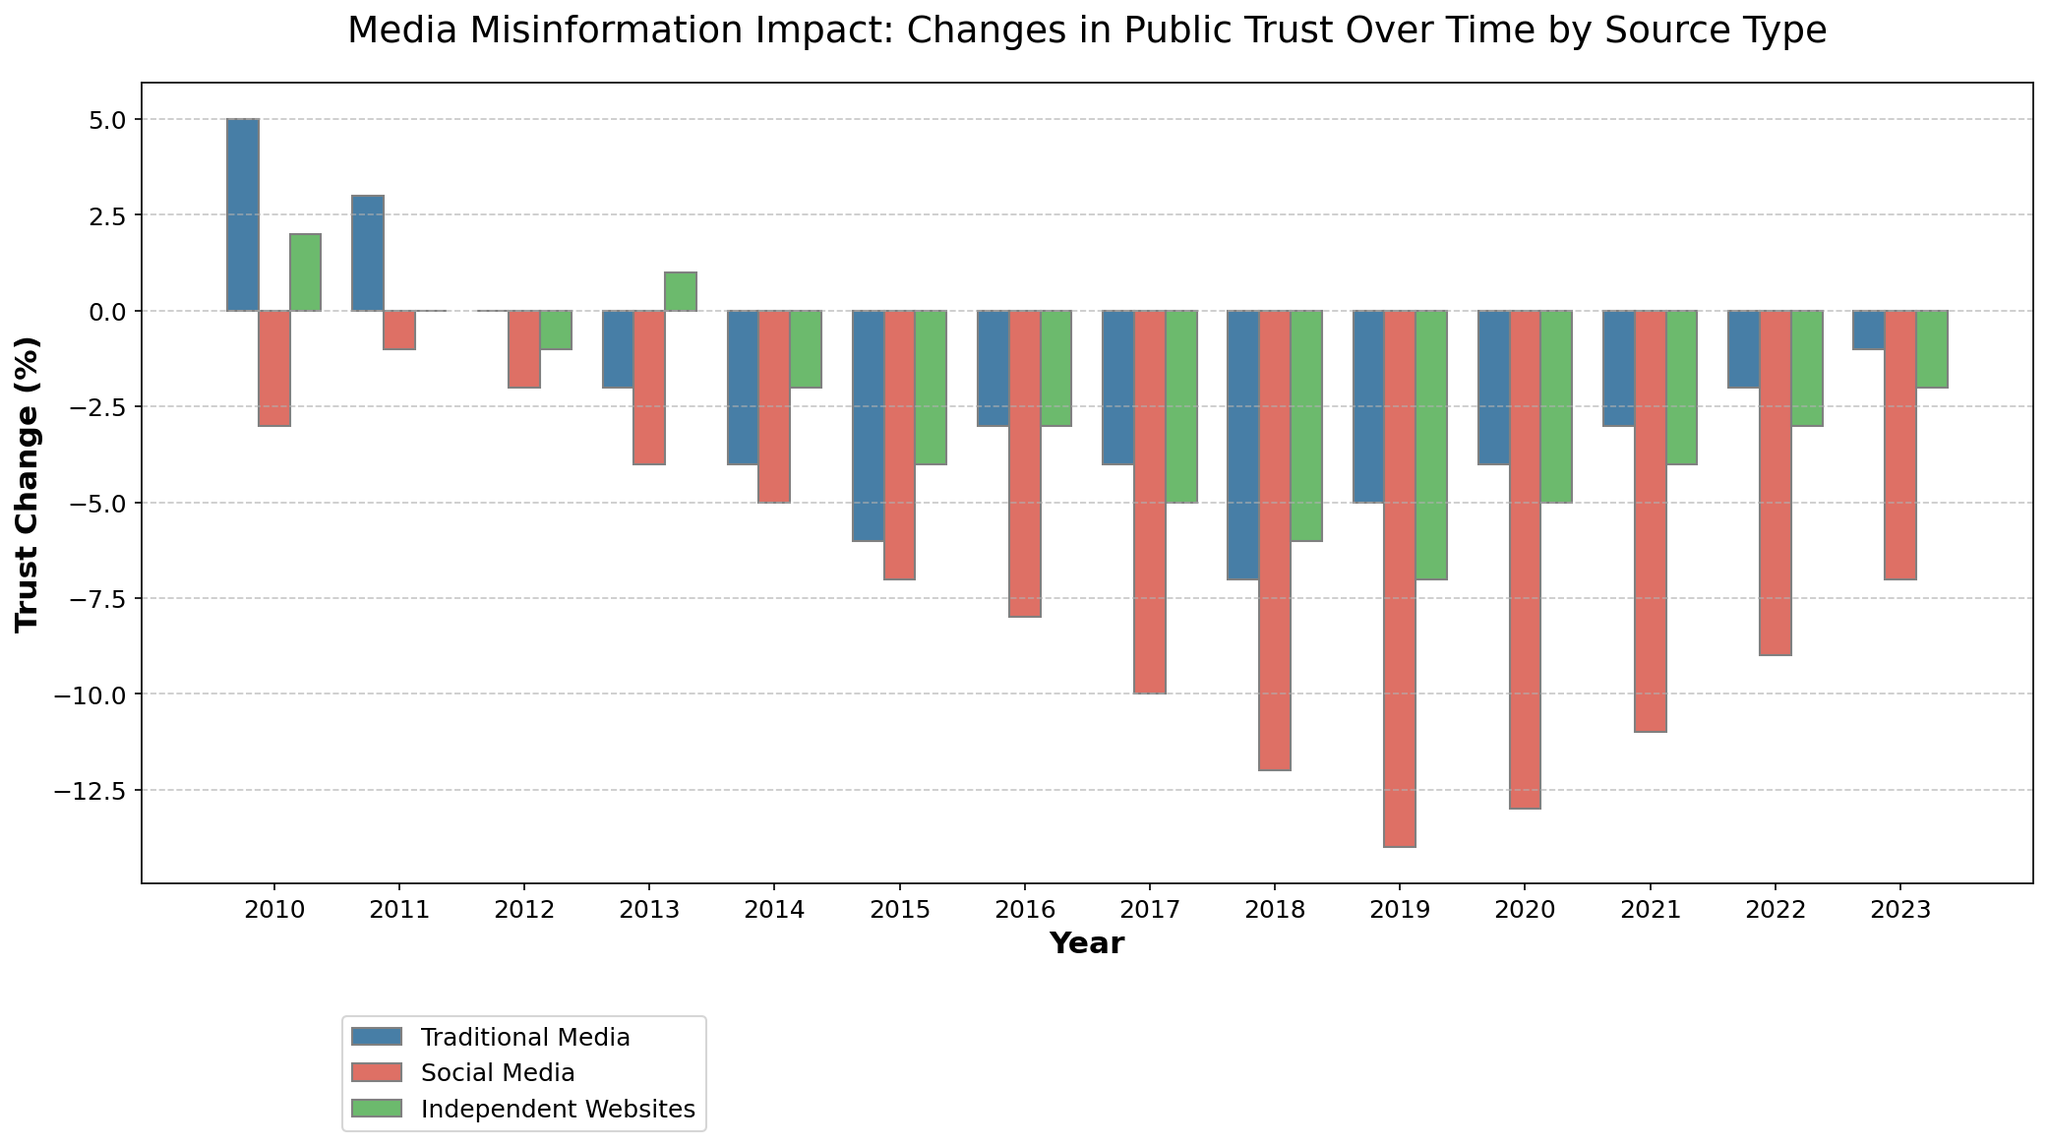Which source type had the largest negative change in public trust in 2019? To find this, look at the height of the bars representing different source types for the year 2019. The tallest bar below zero indicates the largest negative change.
Answer: Social Media How did the change in public trust for Independent Websites behave from 2016 to 2020? Examine the bars for Independent Websites from 2016 to 2020. Identify the trend by comparing the height of the bars year by year.
Answer: It decreased from -3 to -5 and then improved to -4 Comparing 2010 and 2018, how did the change in public trust for Traditional Media differ? Look at the height of the bars for Traditional Media in 2010 and 2018. Subtract the trust change in 2010 from the trust change in 2018 to get the difference.
Answer: -12 Which year did Social Media see the worst change in public trust? Identify the year where the Social Media bar is the tallest below zero, indicating the worst change in public trust.
Answer: 2019 What is the average trust change for Traditional Media from 2010 to 2023? Calculate the sum of trust changes for Traditional Media from 2010 to 2023, then divide by the total number of years (14). Sum: 5 + 3 + 0 - 2 - 4 - 6 - 3 - 4 - 7 - 5 - 4 - 3 - 2 - 1 = -34. Average = -34/14.
Answer: -2.43 In which year did all source types see a negative change in public trust? Look for the year where all bars (for Traditional Media, Social Media, and Independent Websites) are below zero.
Answer: 2014 Which source showed a steady improvement or least variation in public trust change from 2010 to 2023? Examine the bars over the years for each source type. Identify the source type where changes are consistently close to zero.
Answer: Independent Websites What is the difference between the best and worst year of trust change for Social Media? Identify the year with the highest trust change and the year with the lowest trust change for Social Media. Subtract these values. Best: -1 (2011), Worst: -14 (2019). Difference: -1 - (-14) = 13.
Answer: 13 Which source had the smallest negative change in public trust in 2020? Identify the source type with the shortest bar (closest to zero) for the year 2020.
Answer: Traditional Media During which year was the public trust change in Traditional Media closest to zero? Find the year where the bar for Traditional Media is closest to baseline (zero).
Answer: 2012 